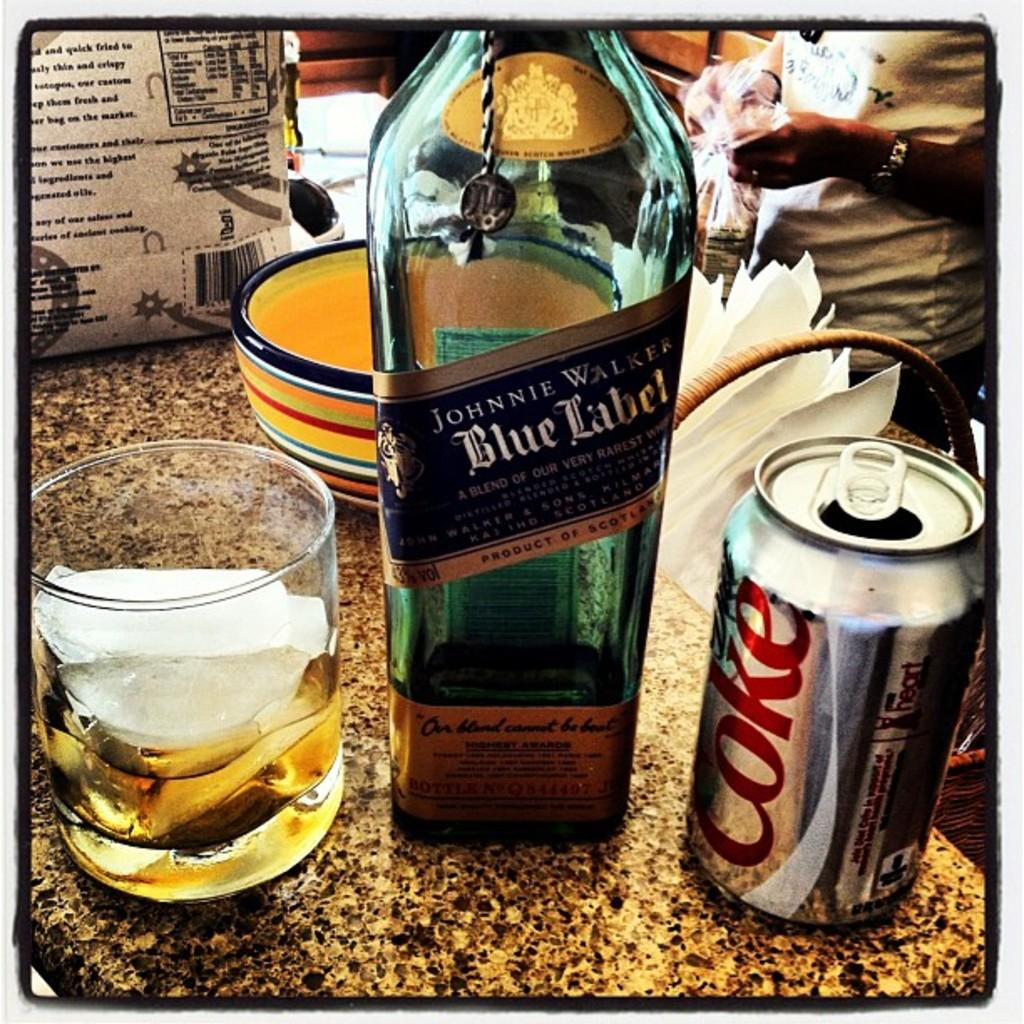<image>
Render a clear and concise summary of the photo. A Johnnie Walker Blue Label bottle stands between a half full glass and an open can of Coke. 